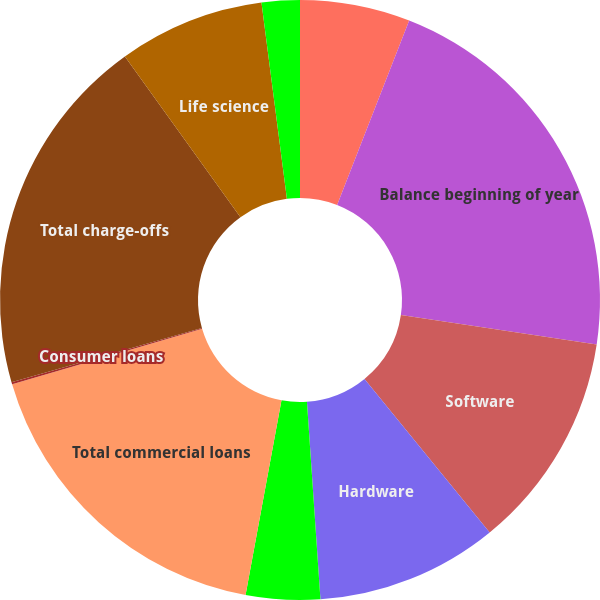Convert chart. <chart><loc_0><loc_0><loc_500><loc_500><pie_chart><fcel>(Dollars in thousands)<fcel>Balance beginning of year<fcel>Software<fcel>Hardware<fcel>Premium wine<fcel>Total commercial loans<fcel>Consumer loans<fcel>Total charge-offs<fcel>Life science<fcel>Other<nl><fcel>5.93%<fcel>21.44%<fcel>11.74%<fcel>9.81%<fcel>3.99%<fcel>17.56%<fcel>0.12%<fcel>19.5%<fcel>7.87%<fcel>2.05%<nl></chart> 